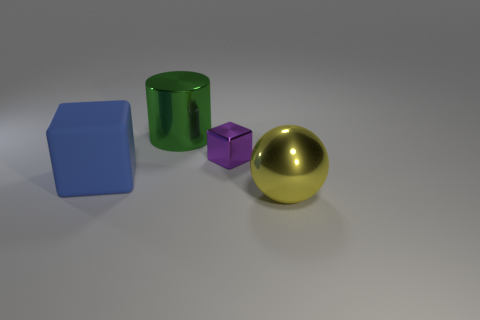There is a big shiny object that is right of the cylinder; is it the same shape as the blue rubber thing?
Make the answer very short. No. There is a yellow thing on the right side of the big shiny object to the left of the big metal object that is to the right of the green thing; what size is it?
Your answer should be very brief. Large. How many objects are big green cylinders or blue matte things?
Your answer should be very brief. 2. What shape is the thing that is to the right of the blue cube and on the left side of the tiny purple block?
Provide a short and direct response. Cylinder. Does the large blue matte thing have the same shape as the shiny thing that is in front of the purple metal object?
Keep it short and to the point. No. Are there any yellow metal objects to the left of the yellow thing?
Provide a short and direct response. No. How many blocks are either big blue matte things or purple metallic things?
Provide a succinct answer. 2. Is the yellow metal thing the same shape as the green object?
Offer a terse response. No. There is a block that is in front of the purple metal object; how big is it?
Your response must be concise. Large. Are there any metallic objects of the same color as the cylinder?
Your response must be concise. No. 